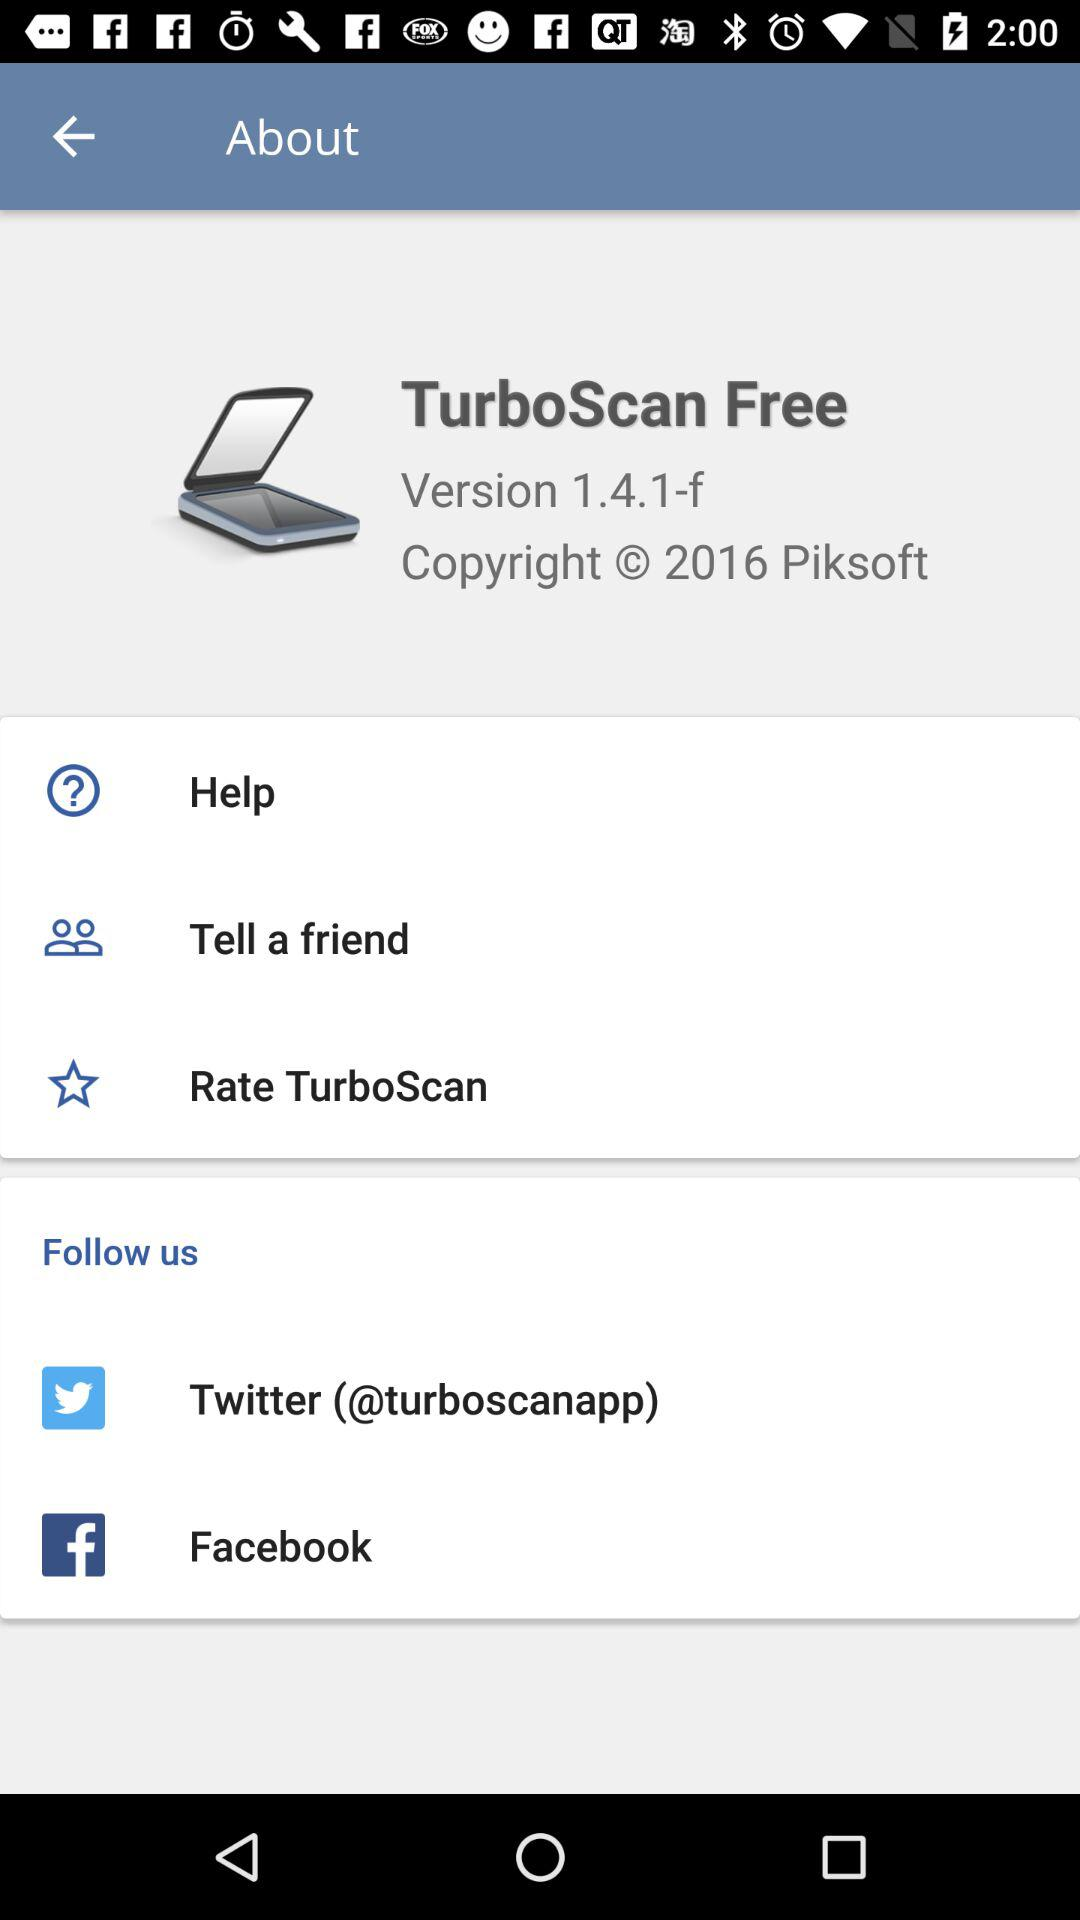What is the application name? The application name is "TurboScan Free". 